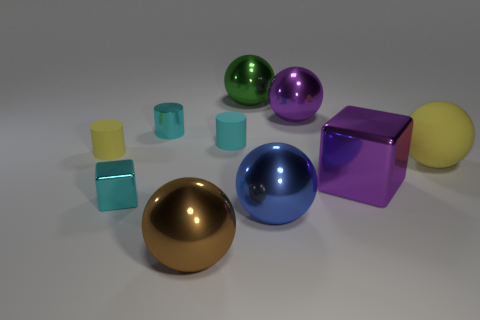The metal cylinder that is the same color as the tiny metal block is what size?
Your answer should be very brief. Small. What is the shape of the big yellow rubber object?
Provide a short and direct response. Sphere. Is the number of matte spheres that are in front of the cyan cube the same as the number of tiny cylinders behind the tiny cyan matte cylinder?
Offer a terse response. No. There is a small thing that is in front of the large yellow matte thing; is it the same color as the rubber cylinder that is to the right of the small metallic block?
Your answer should be very brief. Yes. Is the number of cyan things behind the cyan metal block greater than the number of tiny green rubber blocks?
Keep it short and to the point. Yes. There is a purple thing that is the same material as the purple sphere; what is its shape?
Your response must be concise. Cube. Do the metallic ball that is left of the green shiny sphere and the small metal cylinder have the same size?
Your answer should be compact. No. The cyan object in front of the yellow thing that is on the left side of the big green thing is what shape?
Make the answer very short. Cube. There is a cyan cylinder on the right side of the cyan cylinder that is on the left side of the brown object; how big is it?
Offer a very short reply. Small. What is the color of the shiny ball that is on the right side of the blue ball?
Give a very brief answer. Purple. 